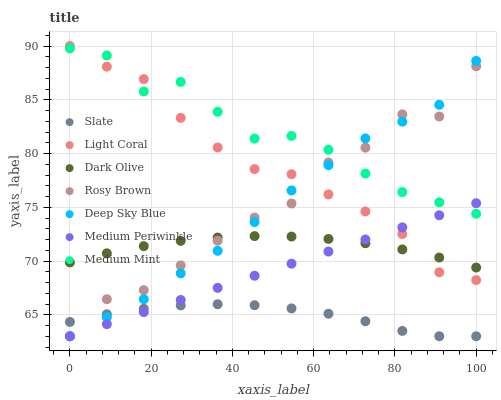Does Slate have the minimum area under the curve?
Answer yes or no. Yes. Does Medium Mint have the maximum area under the curve?
Answer yes or no. Yes. Does Rosy Brown have the minimum area under the curve?
Answer yes or no. No. Does Rosy Brown have the maximum area under the curve?
Answer yes or no. No. Is Medium Periwinkle the smoothest?
Answer yes or no. Yes. Is Rosy Brown the roughest?
Answer yes or no. Yes. Is Slate the smoothest?
Answer yes or no. No. Is Slate the roughest?
Answer yes or no. No. Does Rosy Brown have the lowest value?
Answer yes or no. Yes. Does Dark Olive have the lowest value?
Answer yes or no. No. Does Light Coral have the highest value?
Answer yes or no. Yes. Does Rosy Brown have the highest value?
Answer yes or no. No. Is Dark Olive less than Medium Mint?
Answer yes or no. Yes. Is Dark Olive greater than Slate?
Answer yes or no. Yes. Does Medium Periwinkle intersect Deep Sky Blue?
Answer yes or no. Yes. Is Medium Periwinkle less than Deep Sky Blue?
Answer yes or no. No. Is Medium Periwinkle greater than Deep Sky Blue?
Answer yes or no. No. Does Dark Olive intersect Medium Mint?
Answer yes or no. No. 